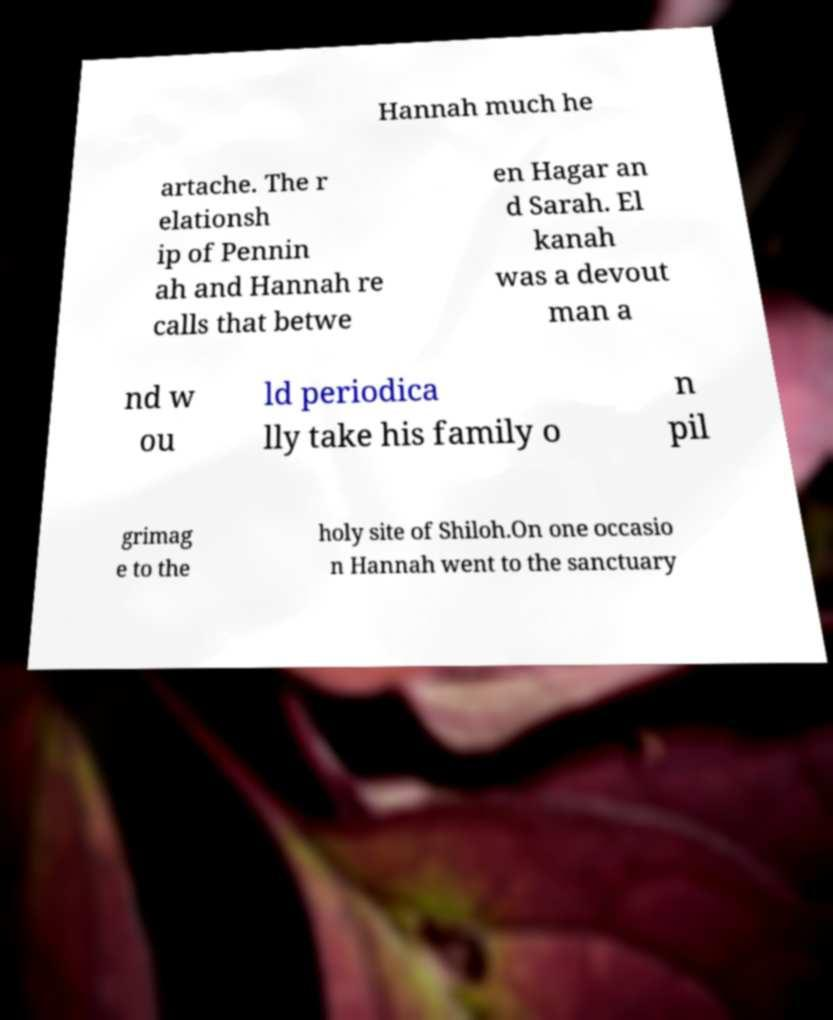For documentation purposes, I need the text within this image transcribed. Could you provide that? Hannah much he artache. The r elationsh ip of Pennin ah and Hannah re calls that betwe en Hagar an d Sarah. El kanah was a devout man a nd w ou ld periodica lly take his family o n pil grimag e to the holy site of Shiloh.On one occasio n Hannah went to the sanctuary 